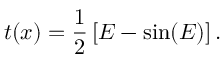Convert formula to latex. <formula><loc_0><loc_0><loc_500><loc_500>t ( x ) = { \frac { 1 } { 2 } } \left [ E - \sin ( E ) \right ] .</formula> 